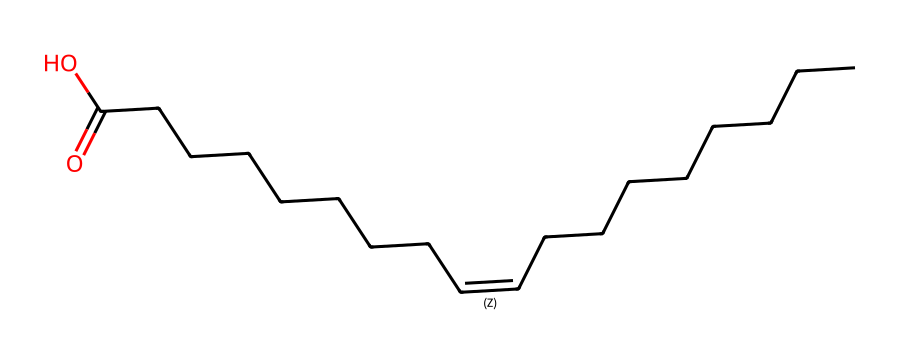what is the common name of this chemical? This SMILES representation corresponds to a fatty acid composed of an 18-carbon chain with a double bond. The common name for this structure is oleic acid.
Answer: oleic acid how many carbon atoms are in oleic acid? The structure indicates a chain of carbon atoms. Counting them reveals there are 18 carbon atoms present in oleic acid.
Answer: 18 what type of bonding is present at the double bond in oleic acid? The double bond in the structure is represented as "/C=C\" indicating a cis or trans configuration specific to alkenes, which suggests it has a carbon-carbon double bond.
Answer: carbon-carbon double bond how many double bonds are present in oleic acid? In the provided structure, there is only one double bond between the two carbon atoms, as indicated by the "/C=C\" notation in the SMILES.
Answer: 1 what is the geometric isomerism present in oleic acid? The presence of the double bond implies that oleic acid can exist in two geometric forms: cis and trans. The specific isomer depends on the arrangement of hydrogen atoms around the double bond.
Answer: cis and trans what functional group is indicated in this chemical? The final part of the SMILES structure, "CCCCCCCC(=O)O", indicates a carboxylic acid functional group (-COOH), which confirms the presence of the acidic characteristic in oleic acid.
Answer: carboxylic acid which geometric isomer of oleic acid is more common in cooking oils? Typically, the cis isomer of oleic acid is found more commonly in cooking oils due to its prevalence in natural sources, while the trans form is less common in natural oils.
Answer: cis 